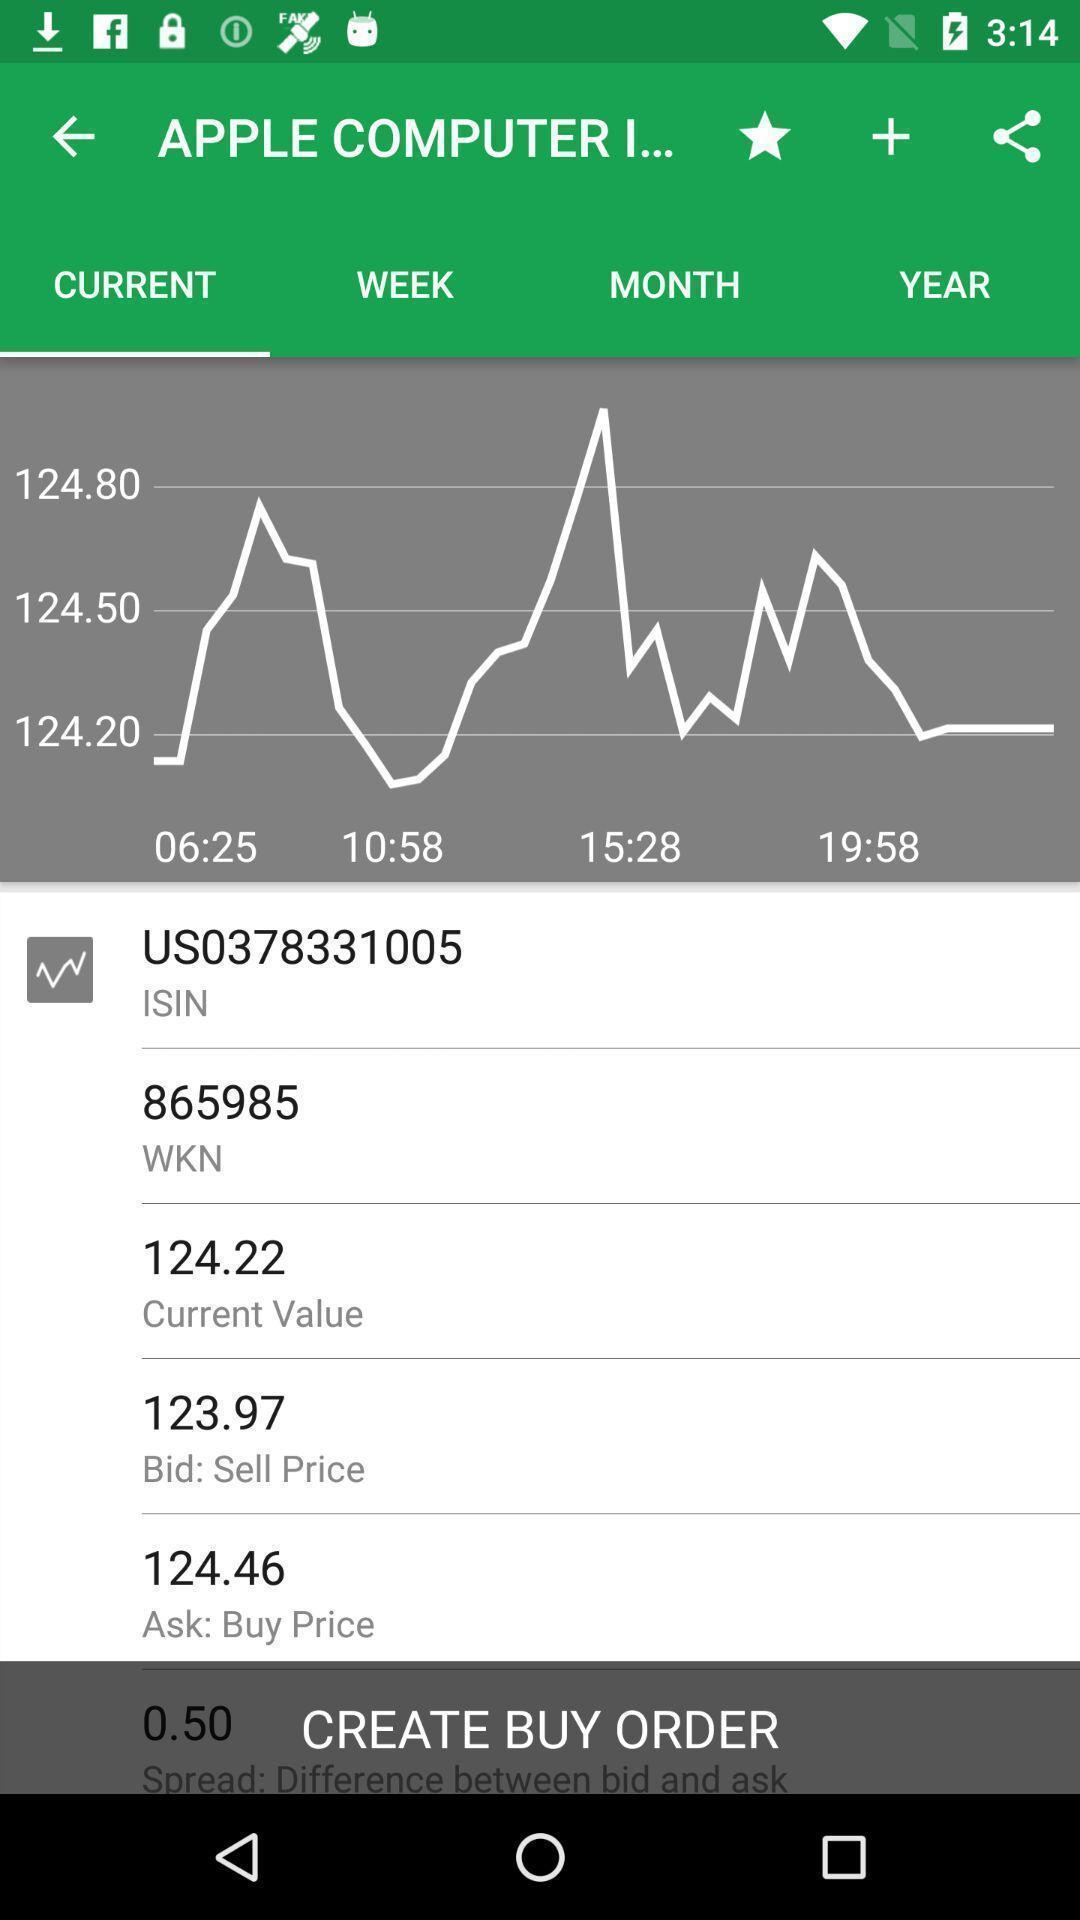Provide a textual representation of this image. Screen shows graphs on an apple computer. 